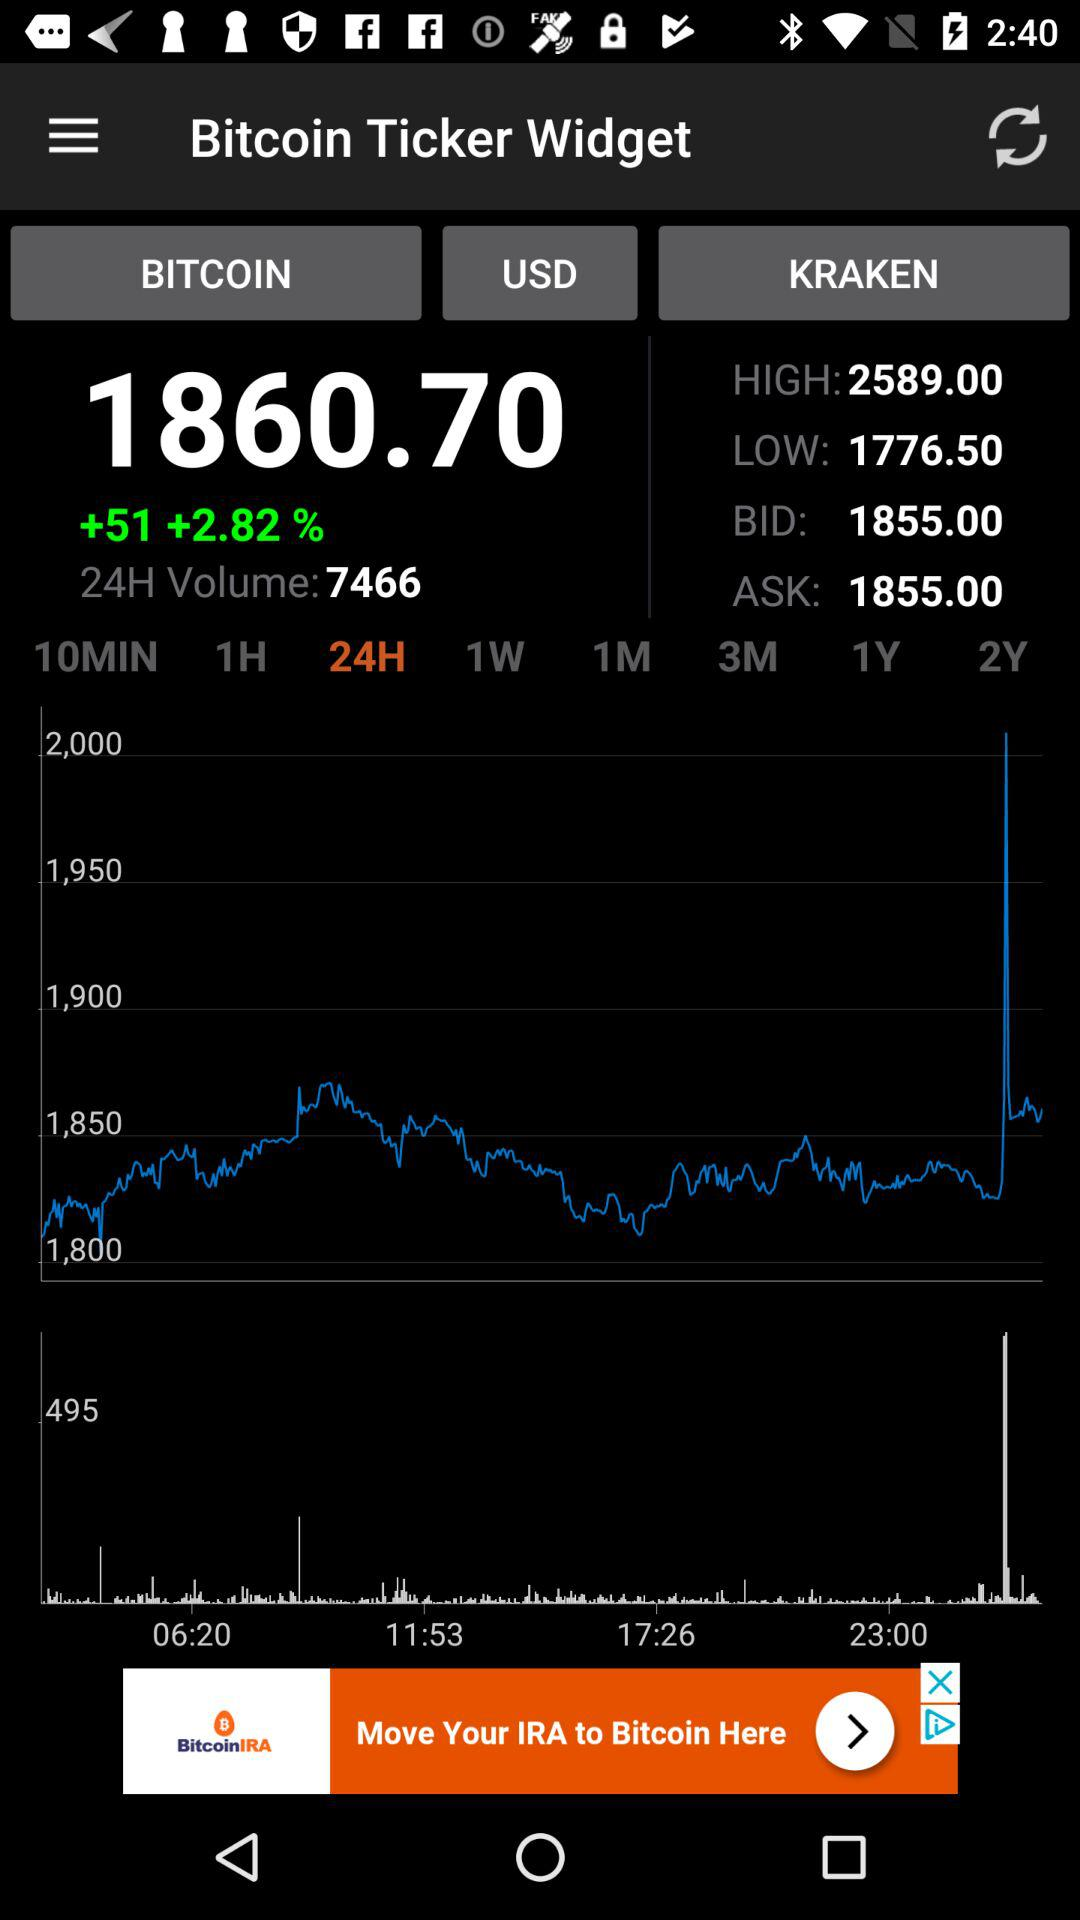What is the value of Bitcoin in US dollars? The value of Bitcoin in US dollars is 1860.70. 